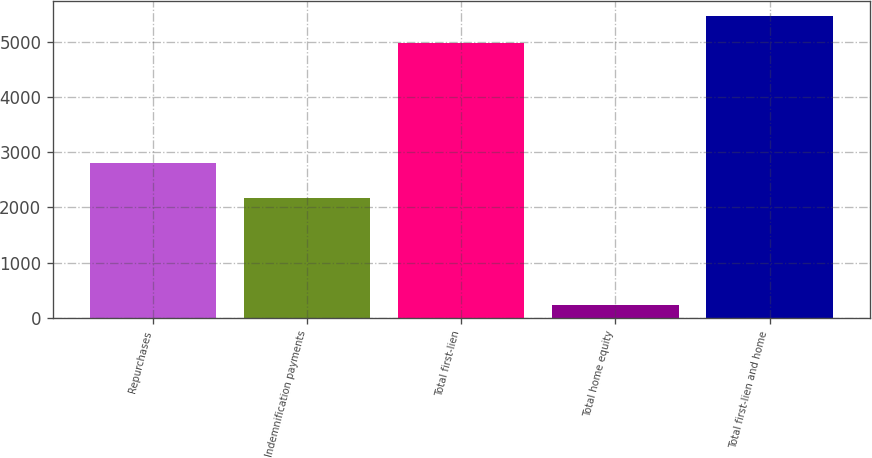<chart> <loc_0><loc_0><loc_500><loc_500><bar_chart><fcel>Repurchases<fcel>Indemnification payments<fcel>Total first-lien<fcel>Total home equity<fcel>Total first-lien and home<nl><fcel>2799<fcel>2173<fcel>4972<fcel>232<fcel>5469.2<nl></chart> 